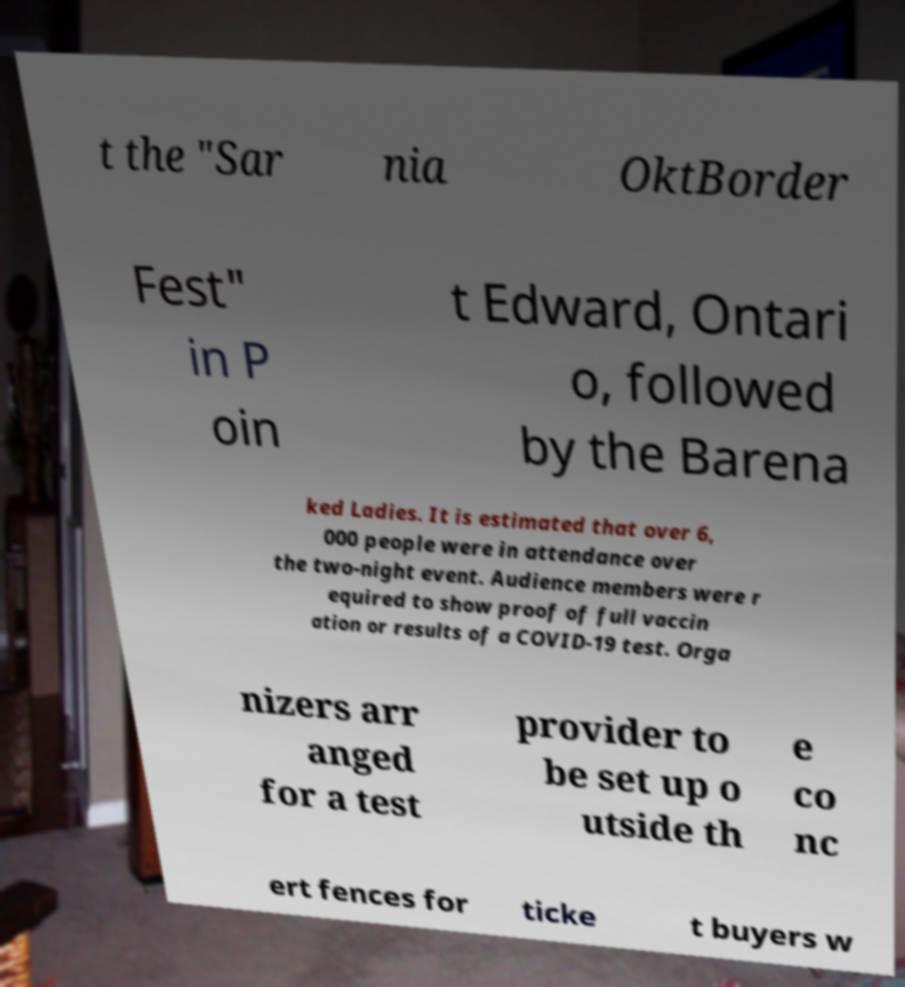Could you assist in decoding the text presented in this image and type it out clearly? t the "Sar nia OktBorder Fest" in P oin t Edward, Ontari o, followed by the Barena ked Ladies. It is estimated that over 6, 000 people were in attendance over the two-night event. Audience members were r equired to show proof of full vaccin ation or results of a COVID-19 test. Orga nizers arr anged for a test provider to be set up o utside th e co nc ert fences for ticke t buyers w 